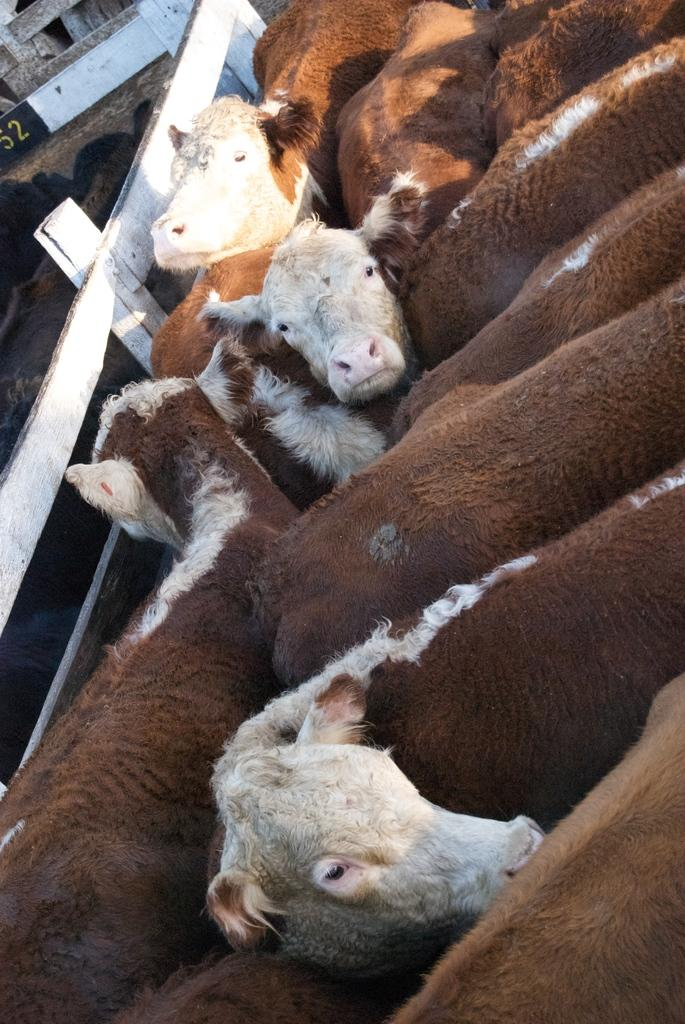What types of animals are in the image? There is a group of animals in the image. What separates the animals from the surrounding area? There is a fence in the image. What can be seen in the distance behind the animals? There is a building in the background of the image. What type of jar is being used as a caption for the image? There is no jar or caption present in the image. 